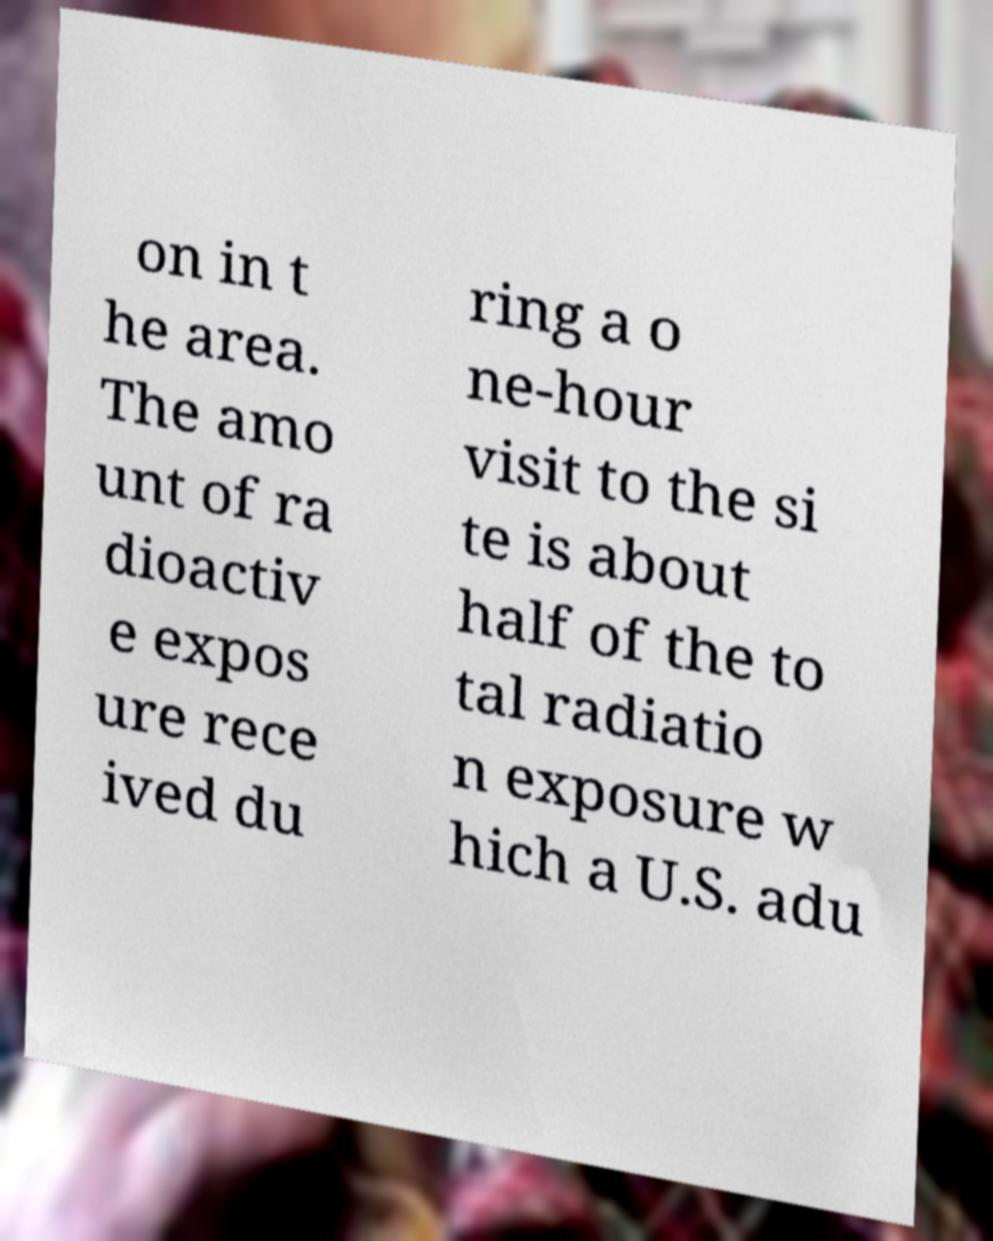What messages or text are displayed in this image? I need them in a readable, typed format. on in t he area. The amo unt of ra dioactiv e expos ure rece ived du ring a o ne-hour visit to the si te is about half of the to tal radiatio n exposure w hich a U.S. adu 